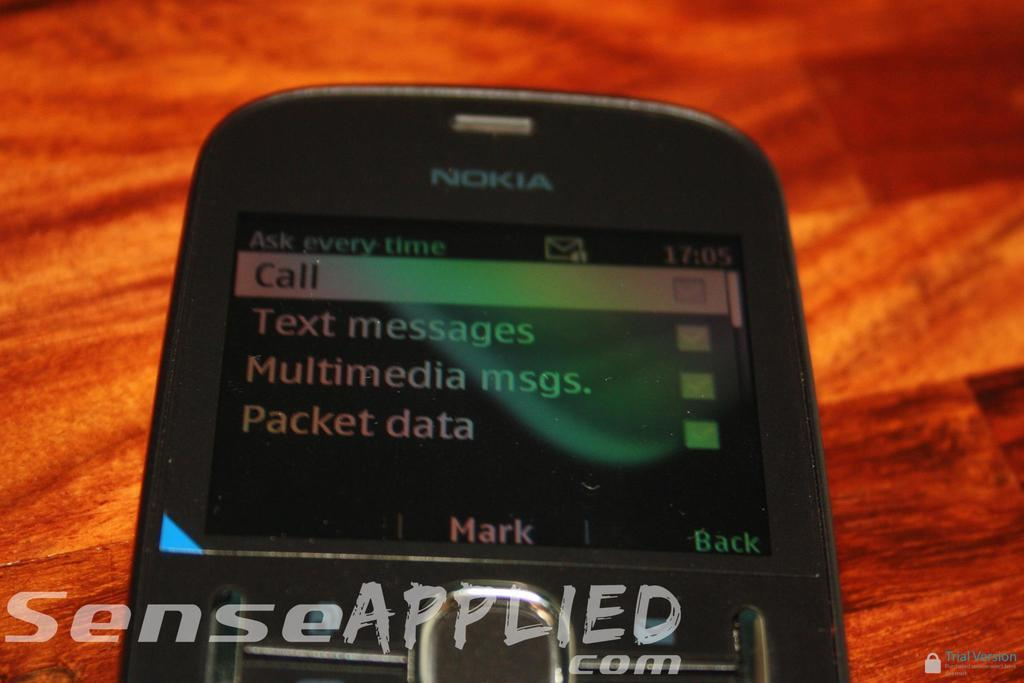<image>
Write a terse but informative summary of the picture. An old Nokia cell phone with the menu screen displayed. 